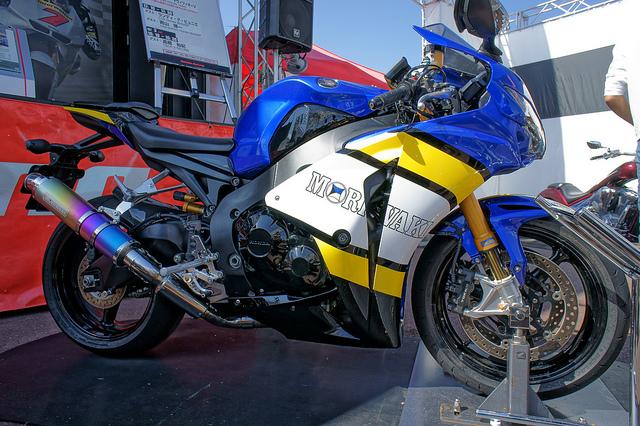What color is the motorcycle?
Write a very short answer. Blue, white and yellow. Which two colors on the motorcycle are primary colors?
Write a very short answer. Blue and yellow. Is this a bike you would normally see on the street?
Keep it brief. Yes. Will someone ride that motorcycle?
Concise answer only. Yes. 